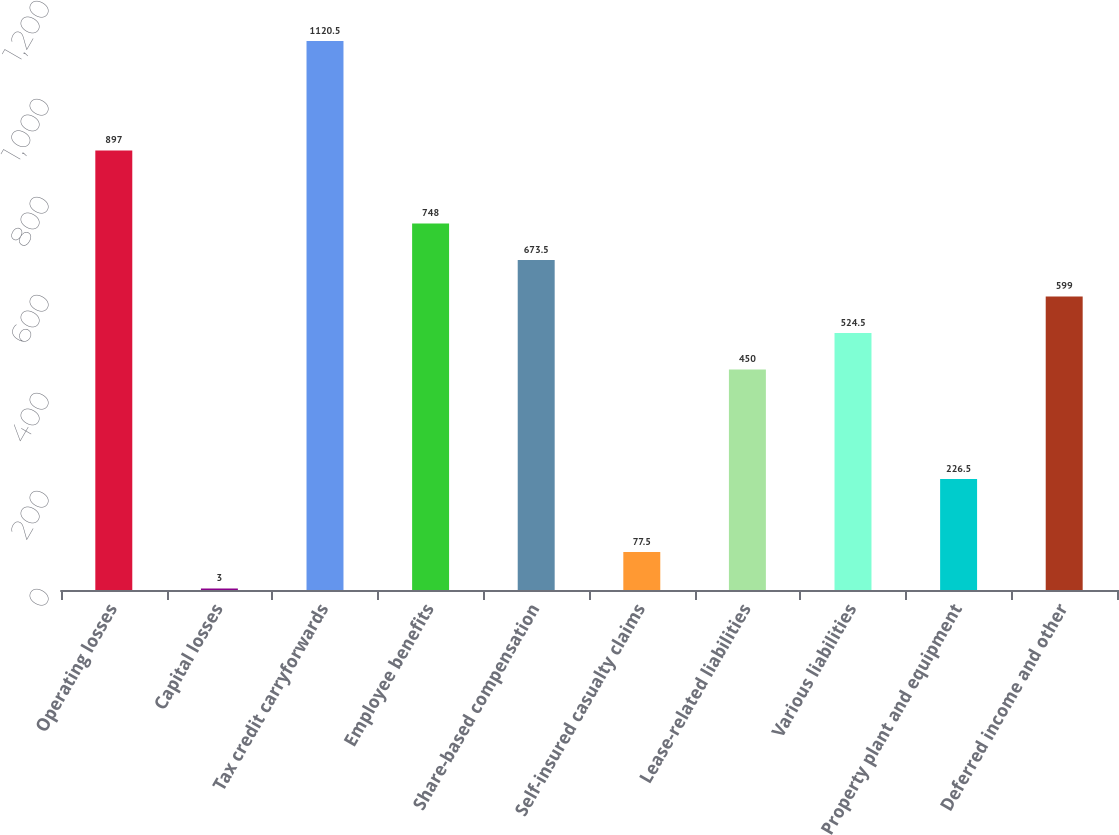Convert chart. <chart><loc_0><loc_0><loc_500><loc_500><bar_chart><fcel>Operating losses<fcel>Capital losses<fcel>Tax credit carryforwards<fcel>Employee benefits<fcel>Share-based compensation<fcel>Self-insured casualty claims<fcel>Lease-related liabilities<fcel>Various liabilities<fcel>Property plant and equipment<fcel>Deferred income and other<nl><fcel>897<fcel>3<fcel>1120.5<fcel>748<fcel>673.5<fcel>77.5<fcel>450<fcel>524.5<fcel>226.5<fcel>599<nl></chart> 